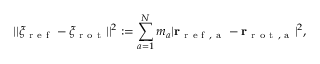<formula> <loc_0><loc_0><loc_500><loc_500>| | \xi _ { r e f } - \xi _ { r o t } | | ^ { 2 } \colon = \sum _ { a = 1 } ^ { N } m _ { a } | r _ { r e f , a } - r _ { r o t , a } | ^ { 2 } ,</formula> 